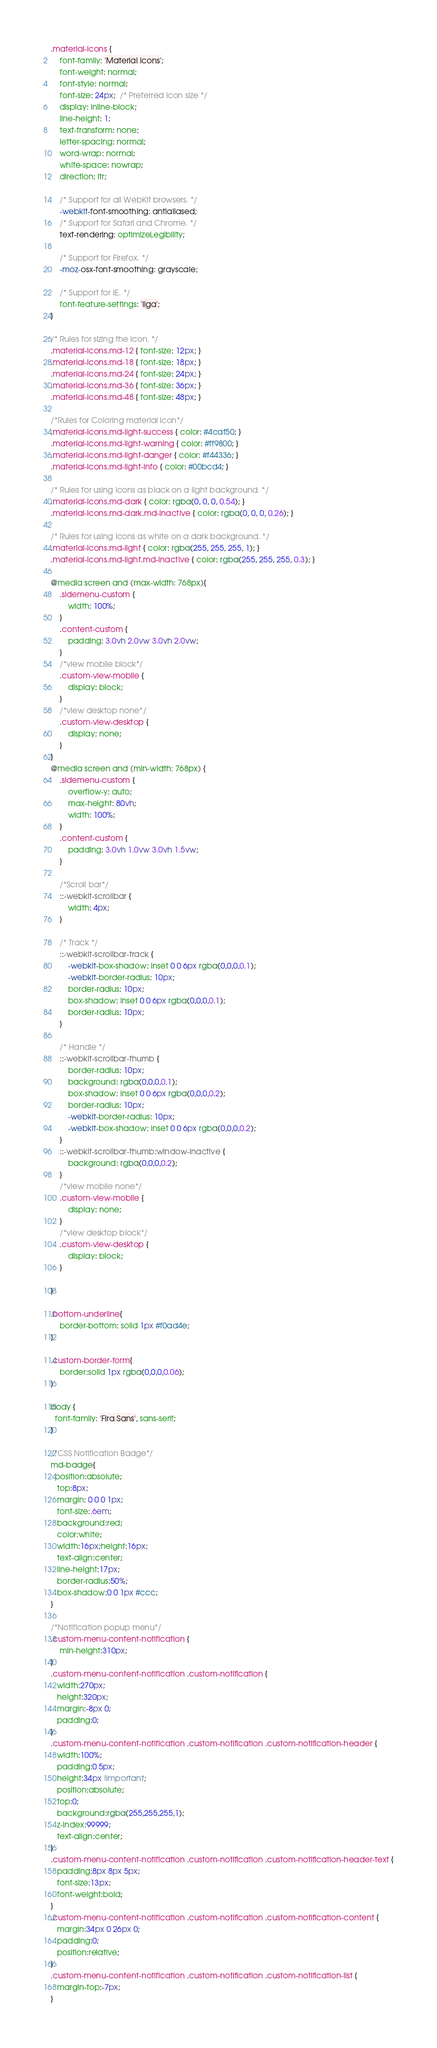Convert code to text. <code><loc_0><loc_0><loc_500><loc_500><_CSS_>.material-icons {
    font-family: 'Material Icons';
    font-weight: normal;
    font-style: normal;
    font-size: 24px;  /* Preferred icon size */
    display: inline-block;
    line-height: 1;
    text-transform: none;
    letter-spacing: normal;
    word-wrap: normal;
    white-space: nowrap;
    direction: ltr;

    /* Support for all WebKit browsers. */
    -webkit-font-smoothing: antialiased;
    /* Support for Safari and Chrome. */
    text-rendering: optimizeLegibility;

    /* Support for Firefox. */
    -moz-osx-font-smoothing: grayscale;

    /* Support for IE. */
    font-feature-settings: 'liga';
}

/* Rules for sizing the icon. */
.material-icons.md-12 { font-size: 12px; }
.material-icons.md-18 { font-size: 18px; }
.material-icons.md-24 { font-size: 24px; }
.material-icons.md-36 { font-size: 36px; }
.material-icons.md-48 { font-size: 48px; }

/*Rules for Coloring material icon*/
.material-icons.md-light-success { color: #4caf50; }
.material-icons.md-light-warning { color: #ff9800; }
.material-icons.md-light-danger { color: #f44336; }
.material-icons.md-light-info { color: #00bcd4; }

/* Rules for using icons as black on a light background. */
.material-icons.md-dark { color: rgba(0, 0, 0, 0.54); }
.material-icons.md-dark.md-inactive { color: rgba(0, 0, 0, 0.26); }

/* Rules for using icons as white on a dark background. */
.material-icons.md-light { color: rgba(255, 255, 255, 1); }
.material-icons.md-light.md-inactive { color: rgba(255, 255, 255, 0.3); }

@media screen and (max-width: 768px){
    .sidemenu-custom {
        width: 100%;
    }
    .content-custom {
        padding: 3.0vh 2.0vw 3.0vh 2.0vw;
    }
    /*view mobile block*/
    .custom-view-mobile {
        display: block;
    }
    /*view desktop none*/
    .custom-view-desktop {
        display: none;
    }
}
@media screen and (min-width: 768px) {
    .sidemenu-custom {
        overflow-y: auto;
        max-height: 80vh;
        width: 100%;
    }
    .content-custom {
        padding: 3.0vh 1.0vw 3.0vh 1.5vw;
    }

    /*Scroll bar*/
    ::-webkit-scrollbar {
        width: 4px;
    }
    
    /* Track */
    ::-webkit-scrollbar-track {
        -webkit-box-shadow: inset 0 0 6px rgba(0,0,0,0.1); 
        -webkit-border-radius: 10px;
        border-radius: 10px;
        box-shadow: inset 0 0 6px rgba(0,0,0,0.1); 
        border-radius: 10px;
    }
    
    /* Handle */
    ::-webkit-scrollbar-thumb {
        border-radius: 10px;
        background: rgba(0,0,0,0.1);
        box-shadow: inset 0 0 6px rgba(0,0,0,0.2); 
        border-radius: 10px;
        -webkit-border-radius: 10px; 
        -webkit-box-shadow: inset 0 0 6px rgba(0,0,0,0.2); 
    }
    ::-webkit-scrollbar-thumb:window-inactive {
        background: rgba(0,0,0,0.2); 
    }
    /*view mobile none*/
    .custom-view-mobile {
        display: none;
    }
    /*view desktop block*/
    .custom-view-desktop {
        display: block;
    }

}

.bottom-underline{
    border-bottom: solid 1px #f0ad4e;
}

.custom-border-form{
    border:solid 1px rgba(0,0,0,0.06);
}

body {
  font-family: 'Fira Sans', sans-serif;
}

/*CSS Notification Badge*/
md-badge{
  position:absolute;
   top:8px;
   margin: 0 0 0 1px;
   font-size:.6em;
   background:red;
   color:white;
   width:16px;height:16px;
   text-align:center;
   line-height:17px;
   border-radius:50%;
   box-shadow:0 0 1px #ccc;
}

/*Notification popup menu*/
.custom-menu-content-notification {
    min-height:310px;
}
.custom-menu-content-notification .custom-notification {
   width:270px;
   height:320px;
   margin:-8px 0;
   padding:0;
}
.custom-menu-content-notification .custom-notification .custom-notification-header {
   width:100%;
   padding:0 5px;
   height:34px !important;
   position:absolute;
   top:0;
   background:rgba(255,255,255,1);
   z-index:99999; 
   text-align:center;
}
.custom-menu-content-notification .custom-notification .custom-notification-header-text {
   padding:8px 8px 5px;
   font-size:13px;
   font-weight:bold;
}
.custom-menu-content-notification .custom-notification .custom-notification-content {
   margin:34px 0 26px 0;
   padding:0;
   position:relative;
}
.custom-menu-content-notification .custom-notification .custom-notification-list {
   margin-top:-7px;
}</code> 